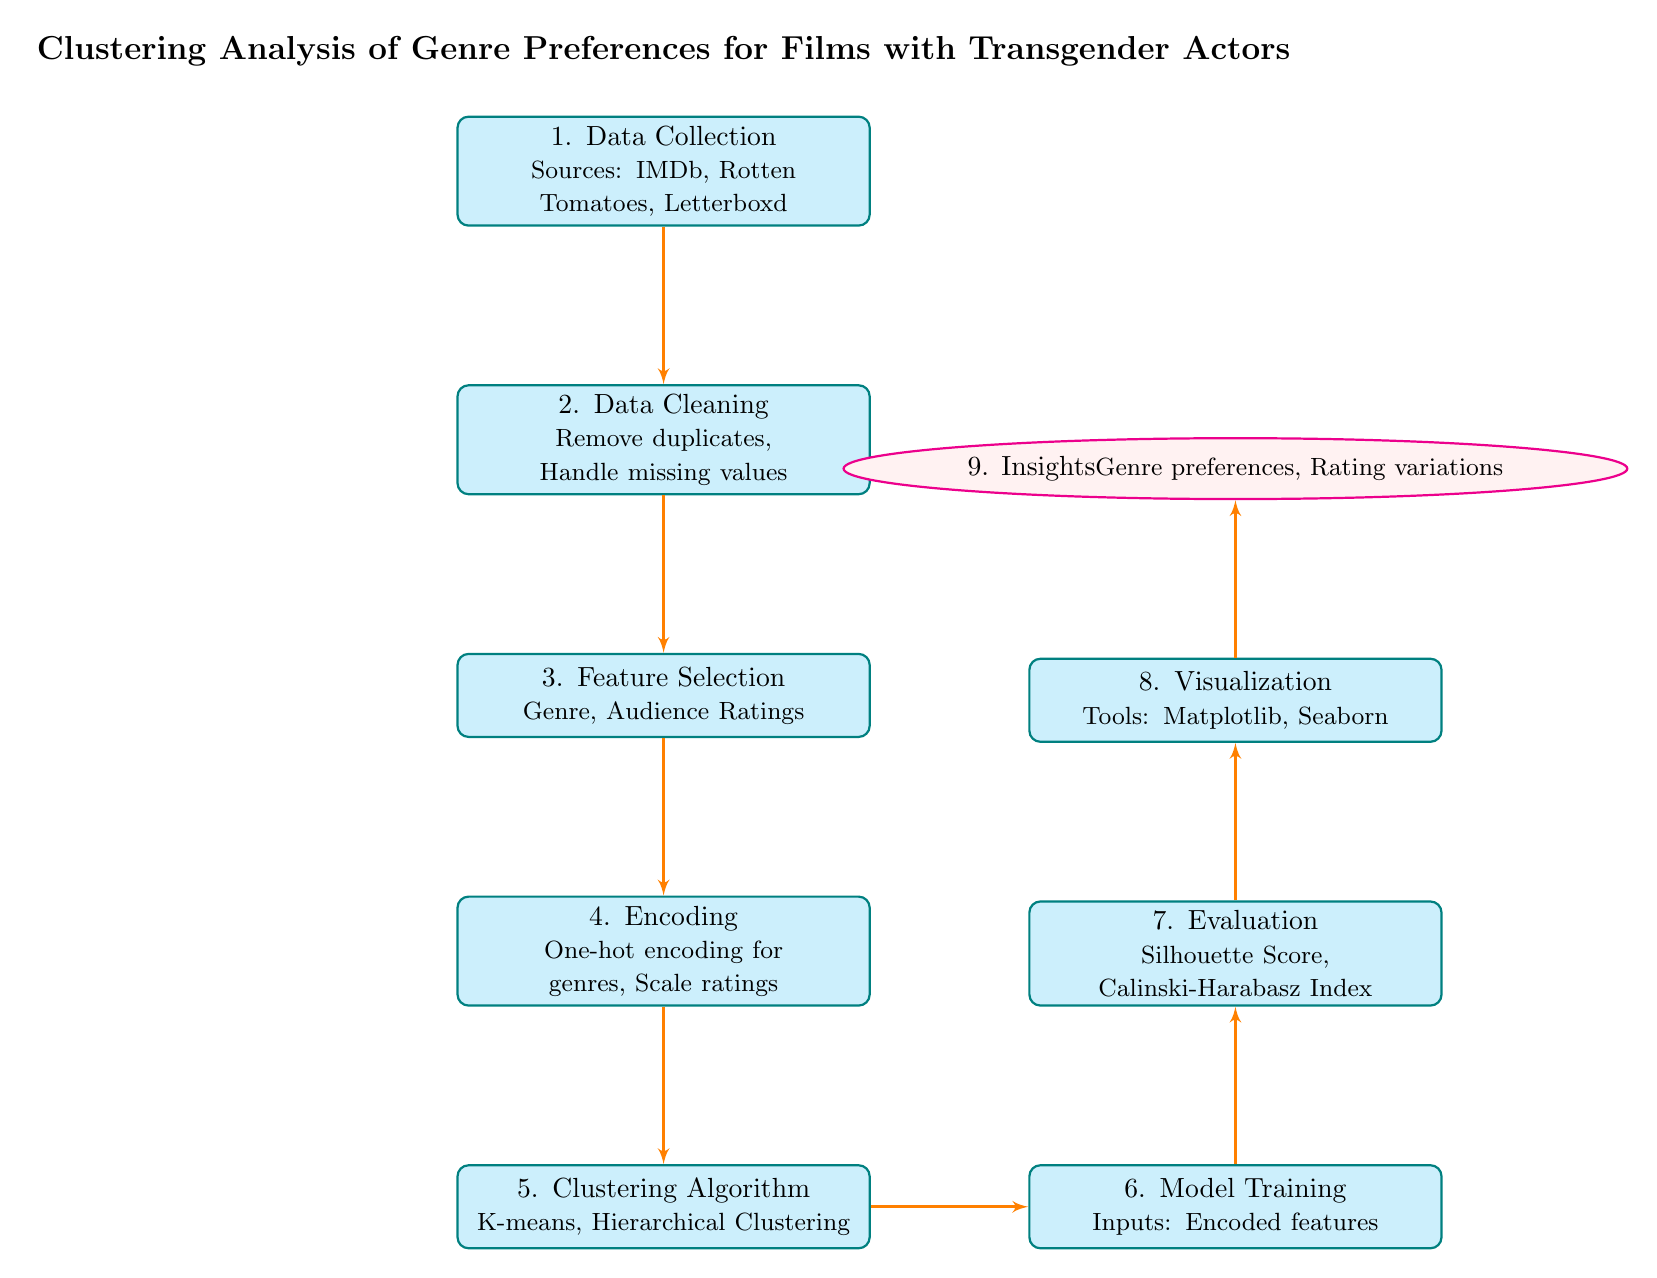What is the first step in the analysis? The first step in the diagram is labeled as "1. Data Collection". This node indicates that gathering data from sources such as IMDb, Rotten Tomatoes, and Letterboxd occurs first.
Answer: Data Collection How many blocks are there in the diagram? The diagram includes eight blocks, each representing a different step in the clustering analysis process. These blocks are numbered from 1 to 8, indicating their sequential order.
Answer: Eight What type of evaluation metric is mentioned? The evaluation metrics mentioned in the diagram include the Silhouette Score and the Calinski-Harabasz Index. These metrics are typically used to assess the quality of clustering methods used in machine learning.
Answer: Silhouette Score Which step comes directly after feature selection? The step that follows feature selection is labeled "4. Encoding". This node discusses the process of applying one-hot encoding for genres and scaling ratings as the next necessary step.
Answer: Encoding What is the output of the eighth step in the process? The eighth step, titled "8. Visualization", indicates that tools like Matplotlib and Seaborn are used for visual representation of the analysis results. This is typically the output phase, where findings are visually communicated.
Answer: Visualization What insights are expected at the end of the analysis? At the end of the analysis, the expected insights include genre preferences and rating variations. This reflects the ultimate goal of the clustering analysis to understand audience preferences better.
Answer: Insights Which clustering algorithm is mentioned in the diagram? The diagram lists two clustering algorithms: K-means and Hierarchical Clustering. These algorithms are essential for grouping the data based on the selected features after encoding.
Answer: K-means, Hierarchical Clustering What is the purpose of data cleaning? The purpose of data cleaning, as indicated in step 2, is to remove duplicates and handle missing values. This step ensures that the dataset is accurate and ready for feature selection.
Answer: Remove duplicates, Handle missing values How are the features prepared before applying the clustering algorithm? Before applying the clustering algorithm, the features undergo a process of encoding, specifically one-hot encoding for genres and scaling for ratings. This prepares the data for effective analysis.
Answer: One-hot encoding, scale ratings 